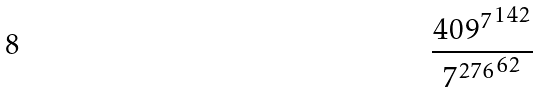Convert formula to latex. <formula><loc_0><loc_0><loc_500><loc_500>\frac { { 4 0 9 ^ { 7 } } ^ { 1 4 2 } } { { 7 ^ { 2 7 6 } } ^ { 6 2 } }</formula> 